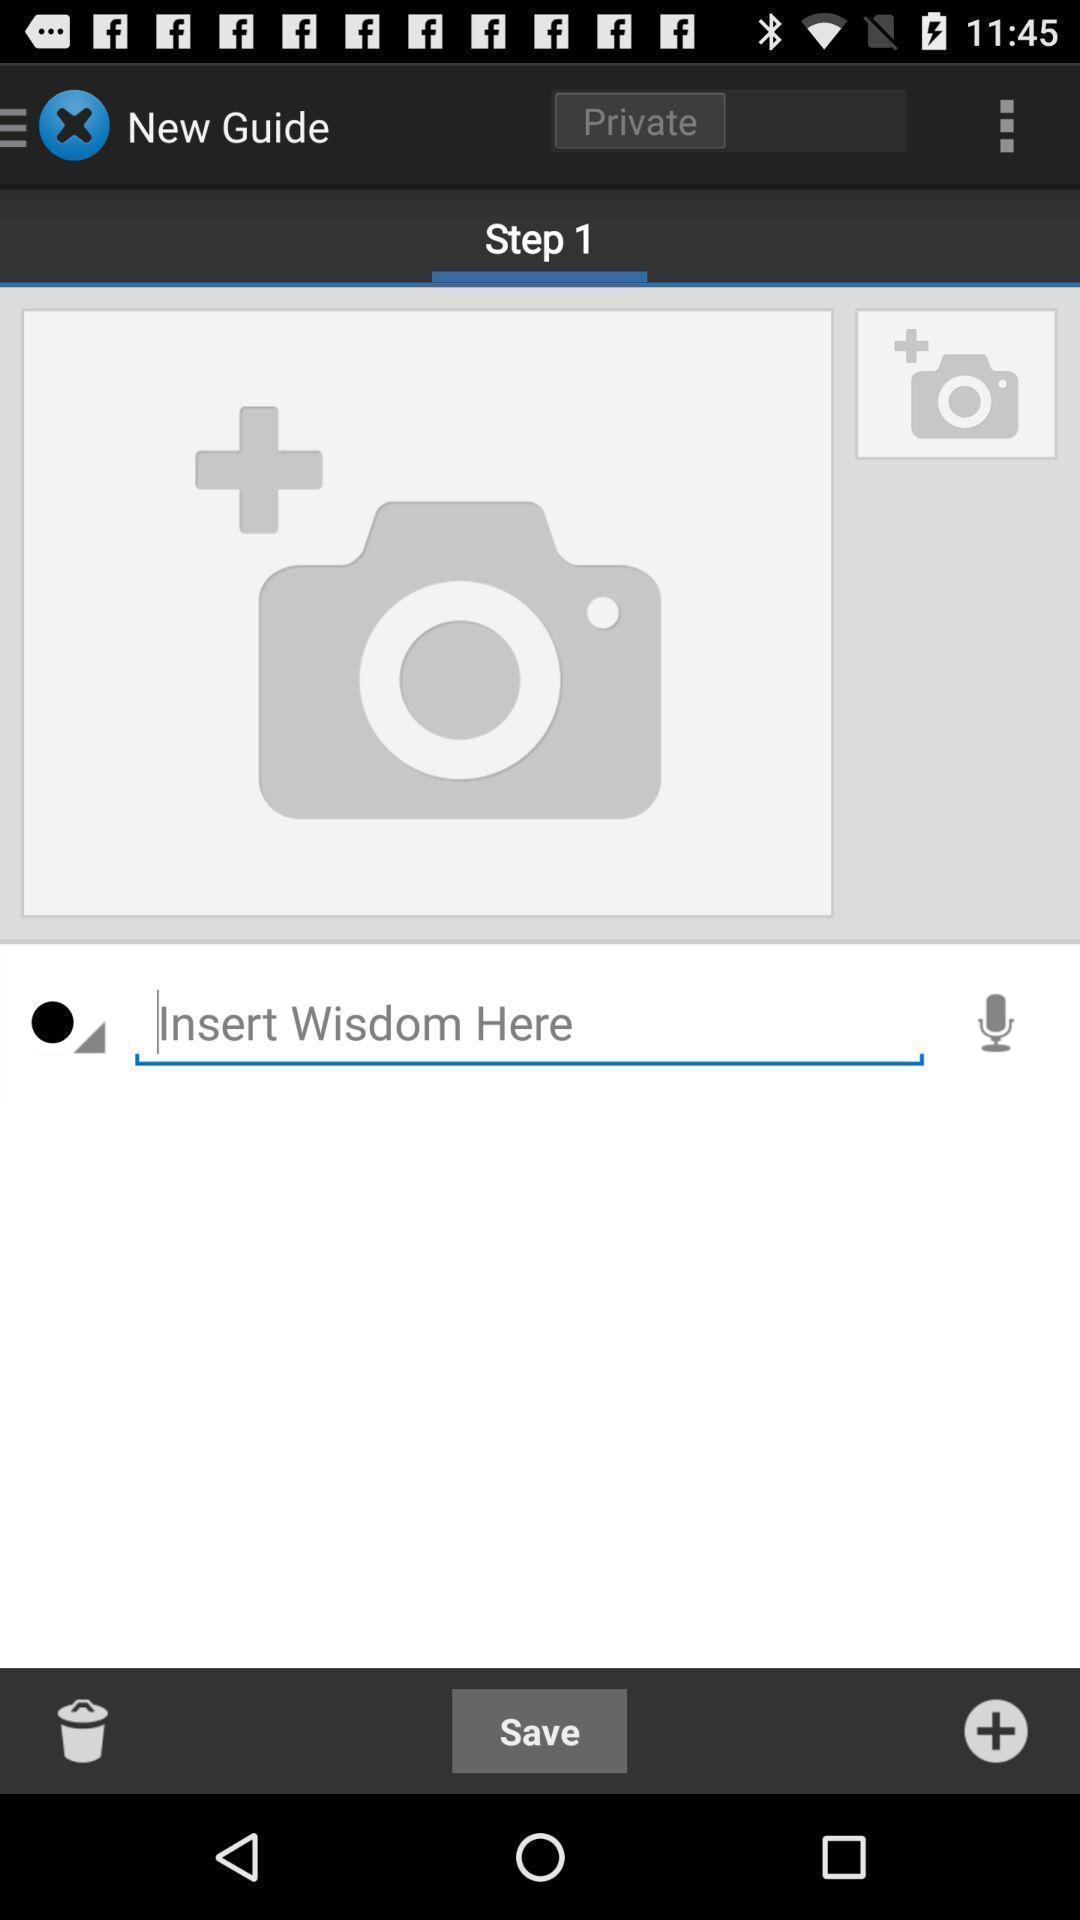Describe the content in this image. Page displaying to complete step 1. 